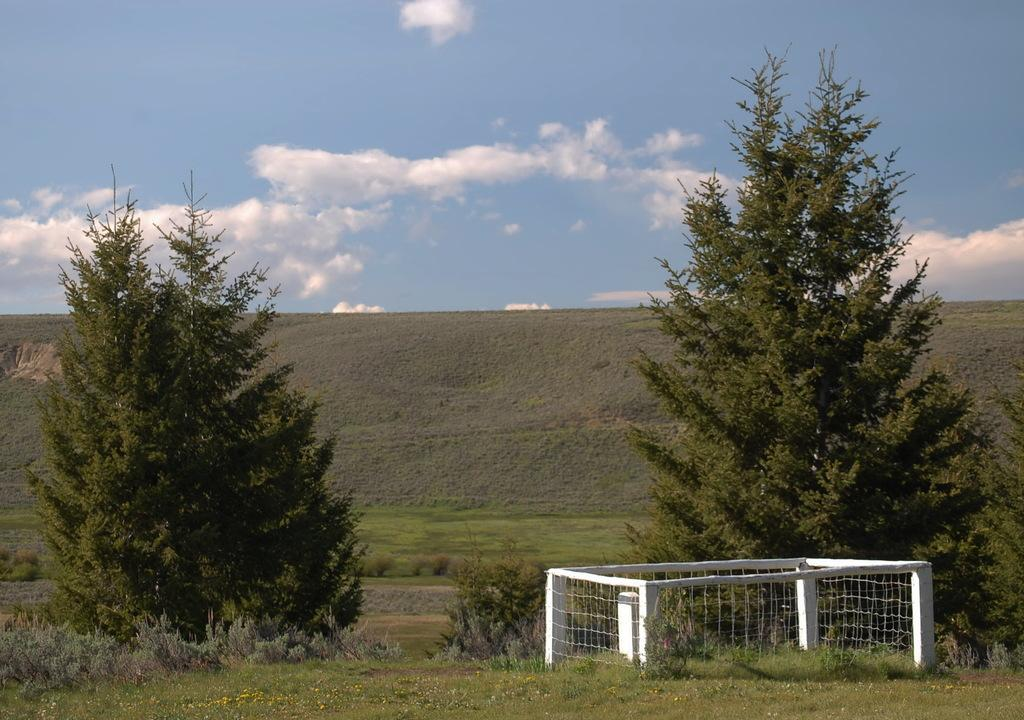What object is present in the image that is white in color? There is a white box in the image. What type of natural elements can be seen on the ground in the image? There are trees on the ground in the image. What geographical feature is visible in the background of the image? There is a hill visible in the background of the image. What can be seen in the sky in the image? There are clouds in the sky in the image. What type of belief system is depicted in the image? There is no indication of any belief system in the image; it primarily features a white box, trees, a hill, and clouds. Can you tell me how many dogs are present in the image? There are no dogs present in the image. 